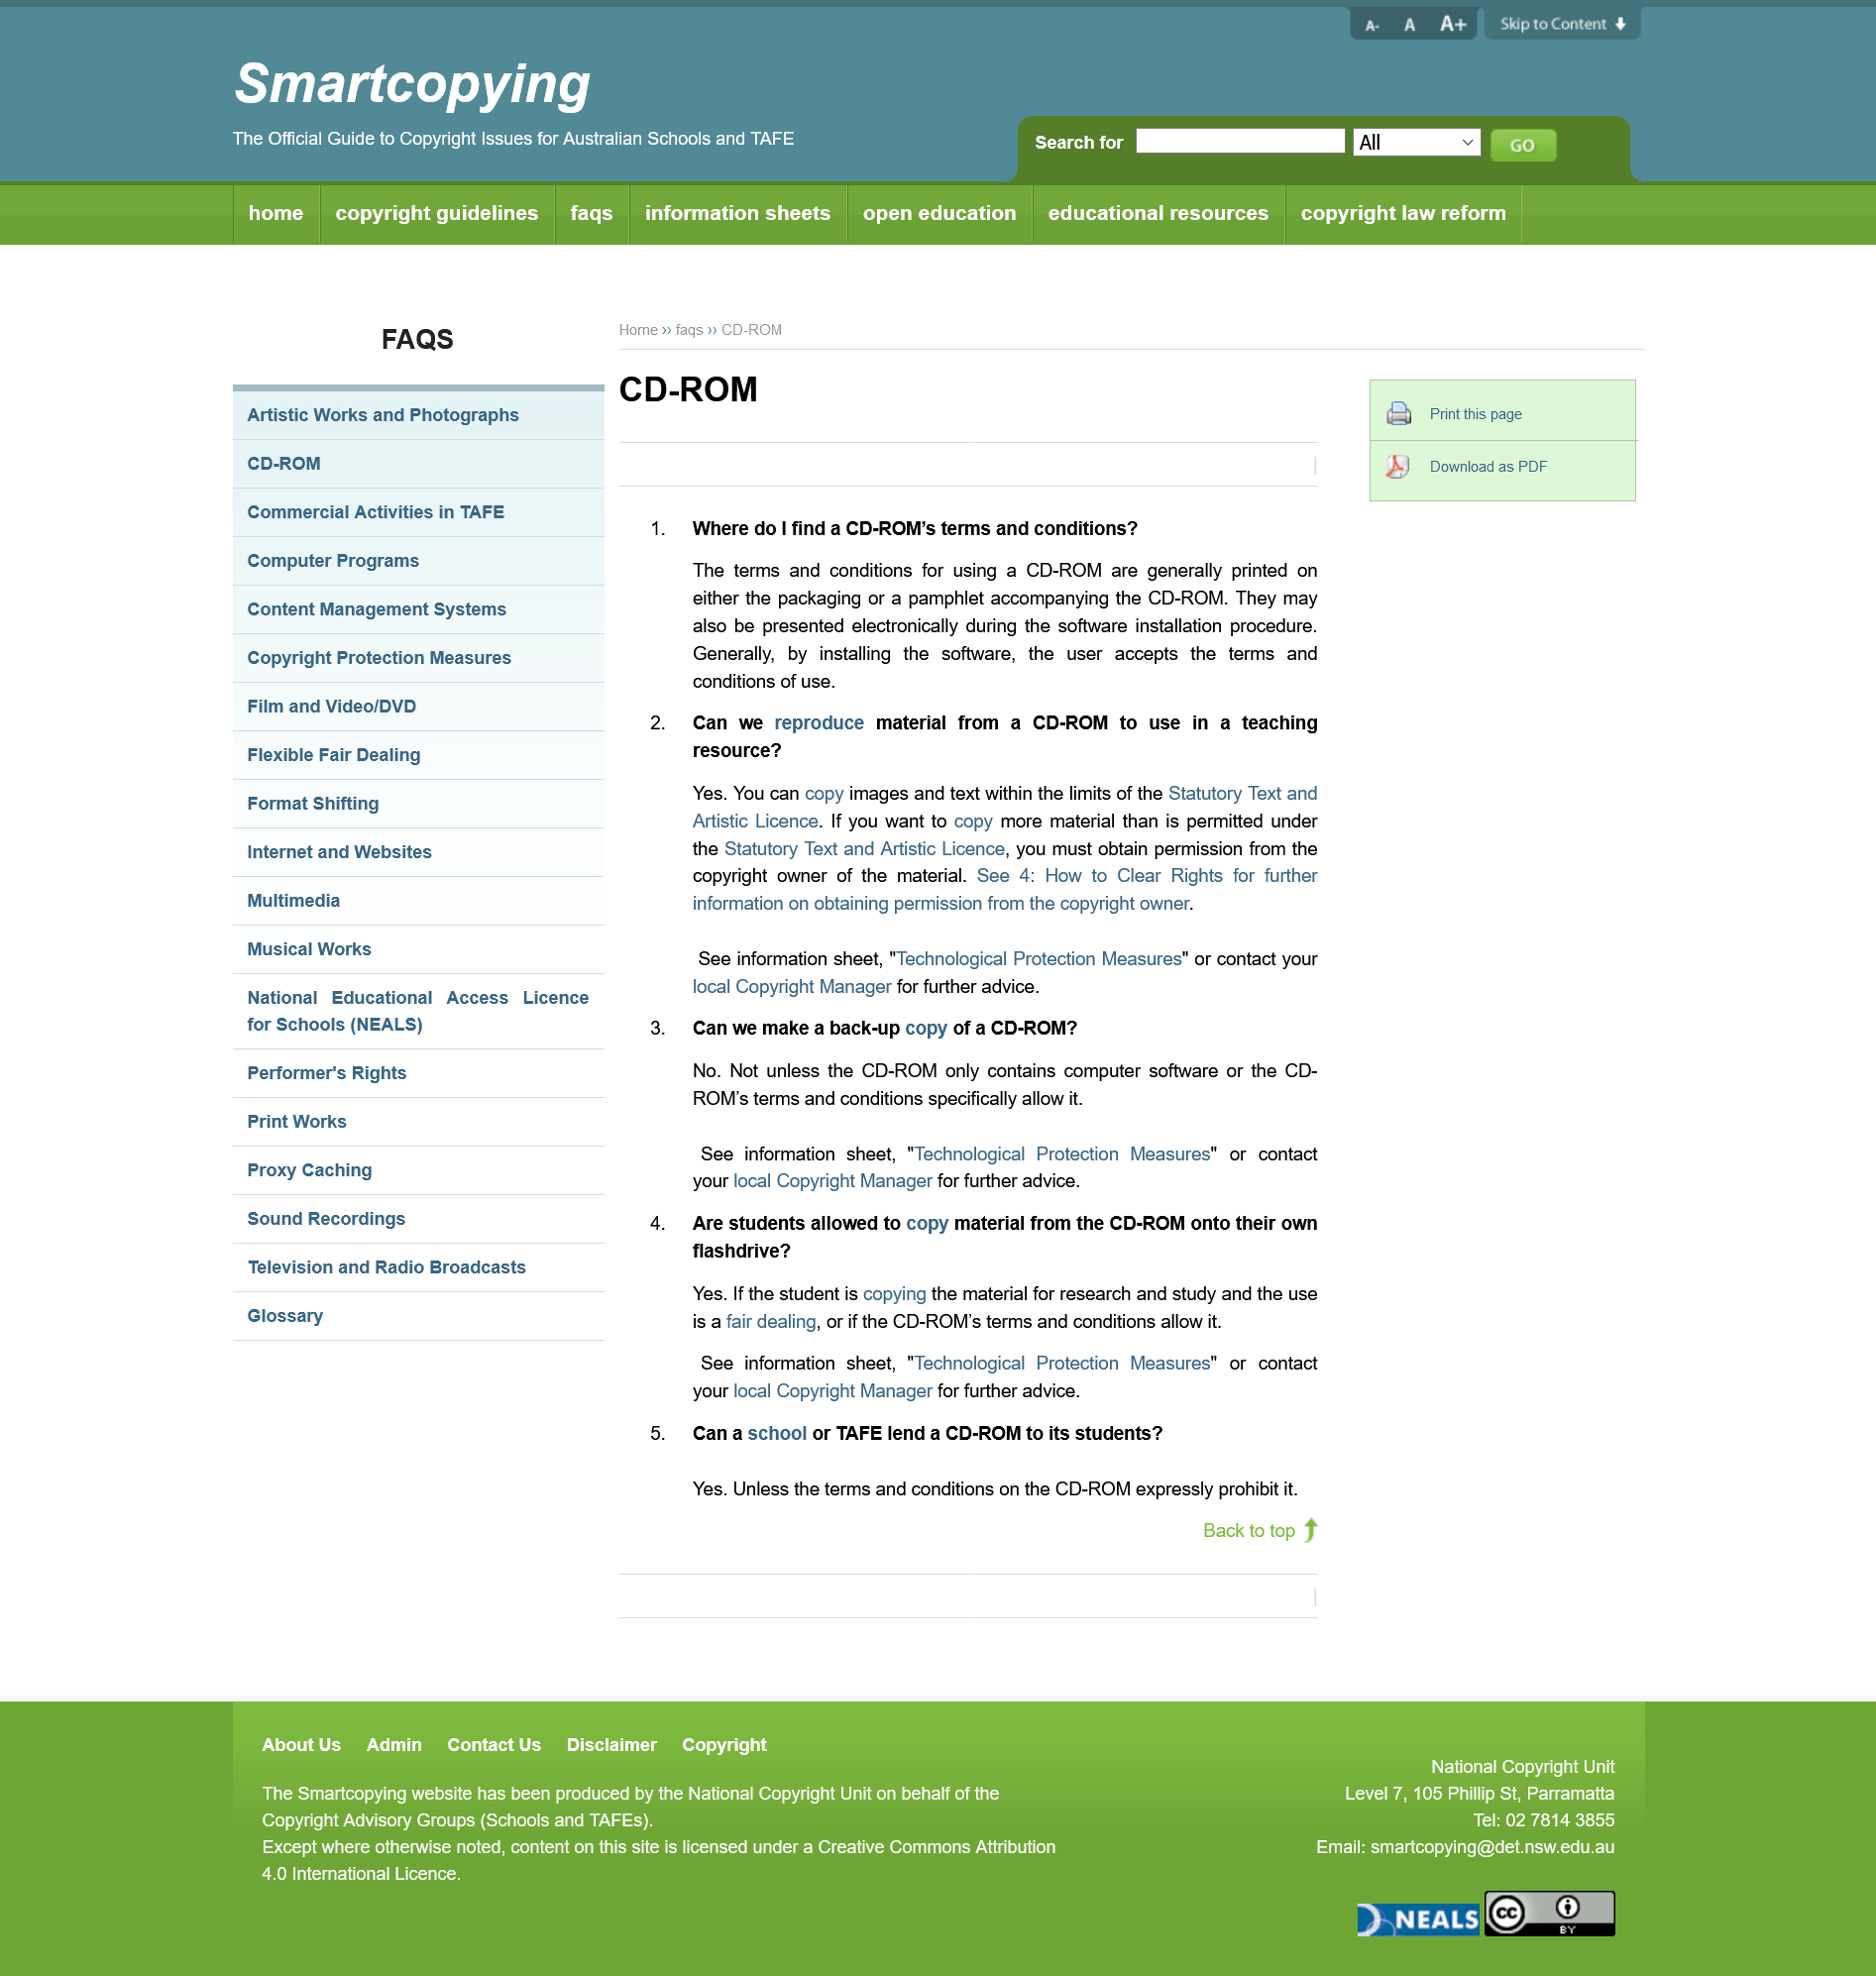List a handful of essential elements in this visual. The terms and conditions for CD-ROMs can typically be found on the packaging or included pamphlet, and not on the actual disc. It is a fact that there are terms and conditions for using CD-ROMS. Yes, I can reproduce materials from a CD ROM and use them in teaching. 